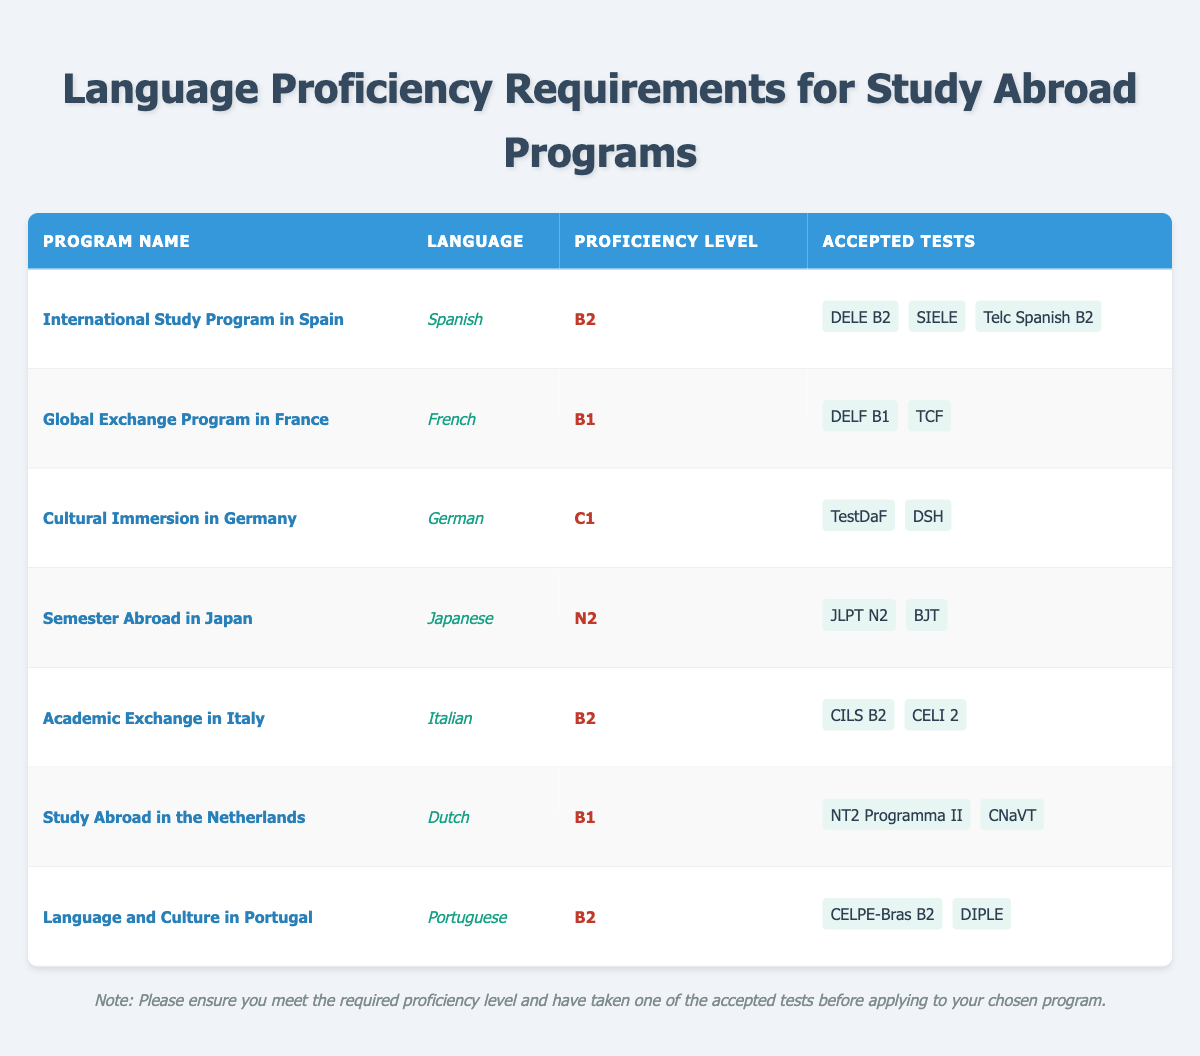What is the required proficiency level for the International Study Program in Spain? The table states that the required proficiency level for the International Study Program in Spain is B2, as indicated in the corresponding row under the "Proficiency Level" column.
Answer: B2 Which language has a C1 proficiency requirement? By checking the table, we can see that the only program with a C1 proficiency level is the Cultural Immersion in Germany. This is specifically listed in the "Proficiency Level" column.
Answer: German How many accepted tests are there for the Academic Exchange in Italy? The table shows that there are two accepted tests for the Academic Exchange in Italy: CILS B2 and CELI 2. Counting the tests in the "Accepted Tests" column for that row, we find two.
Answer: 2 Is it true that the Dutch language requires a B2 proficiency level for the Study Abroad in the Netherlands? The table indicates that the required proficiency level for the Study Abroad in the Netherlands is B1, not B2. Therefore, the statement is false.
Answer: No What is the average proficiency level required for all programs listed? The proficiency levels can be quantified as follows: B2=2, B1=2, C1=1, N2=1. There are a total of 6 proficiency levels when counted. To find the average, we use the values: (2*B2 + 2*B1 + 1*C1 + 1*N2) divided by 6. To simplify, consider B2 as 2, B1 as 1, C1 as 3, and N2 as 4, giving the sum of (2*2 + 2*1 + 3 + 4) = 13 / 6 = approx. 2.17. The average proficiency level is roughly between B1 and B2.
Answer: Between B1 and B2 How many programs require proficiency levels of B2 or higher? The required proficiency levels of B2 or higher include: International Study Program in Spain (B2), Cultural Immersion in Germany (C1), Academic Exchange in Italy (B2), and Language and Culture in Portugal (B2). Thus, we see that there are four programs falling into this category.
Answer: 4 